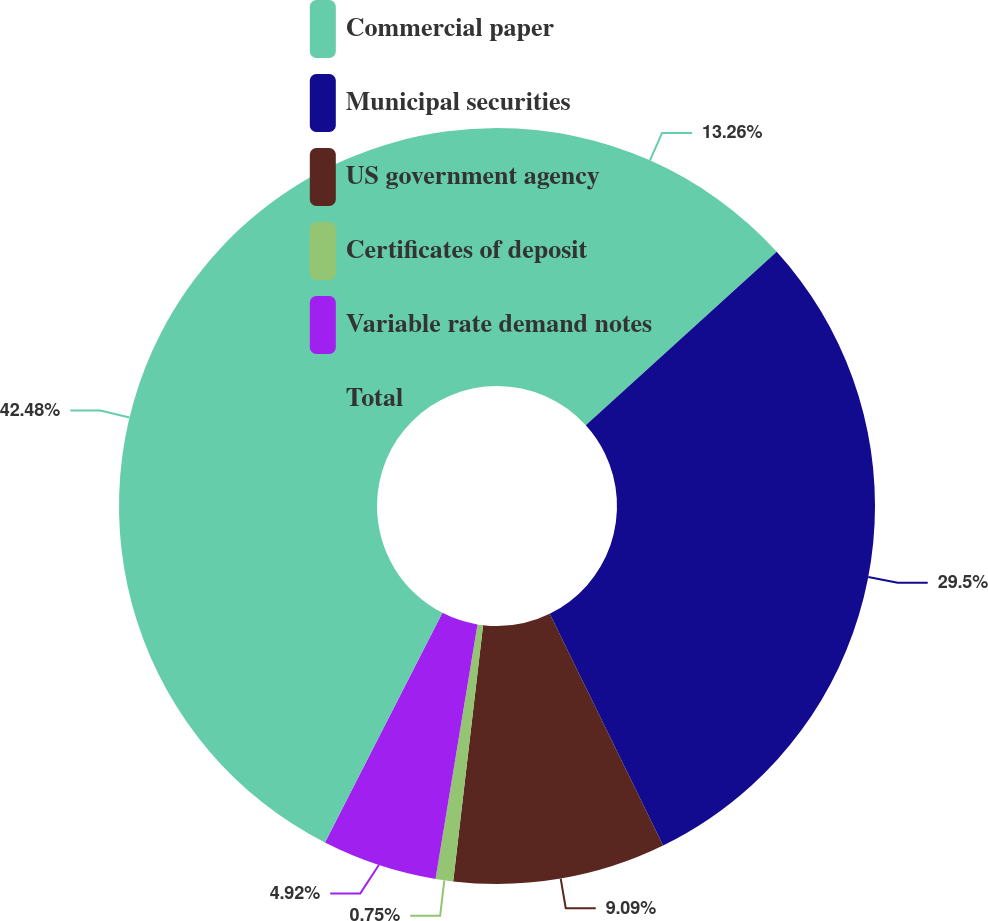Convert chart to OTSL. <chart><loc_0><loc_0><loc_500><loc_500><pie_chart><fcel>Commercial paper<fcel>Municipal securities<fcel>US government agency<fcel>Certificates of deposit<fcel>Variable rate demand notes<fcel>Total<nl><fcel>13.26%<fcel>29.5%<fcel>9.09%<fcel>0.75%<fcel>4.92%<fcel>42.48%<nl></chart> 